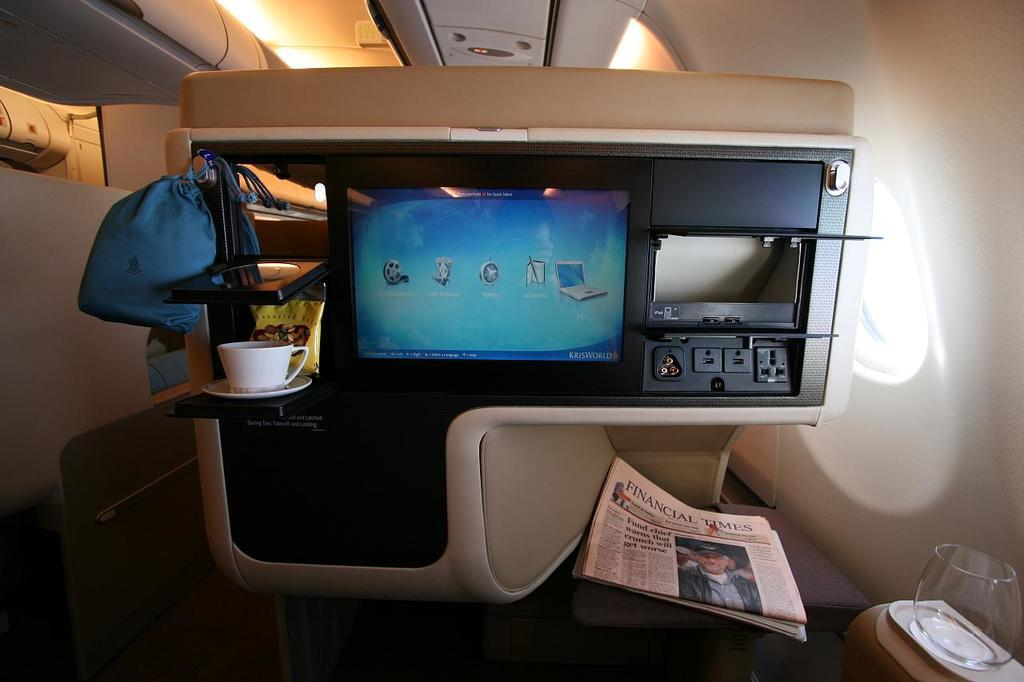<image>
Share a concise interpretation of the image provided. An airplane entertainment console is shown with a screen with several icons and a Financial Times newspaper below the screen. 